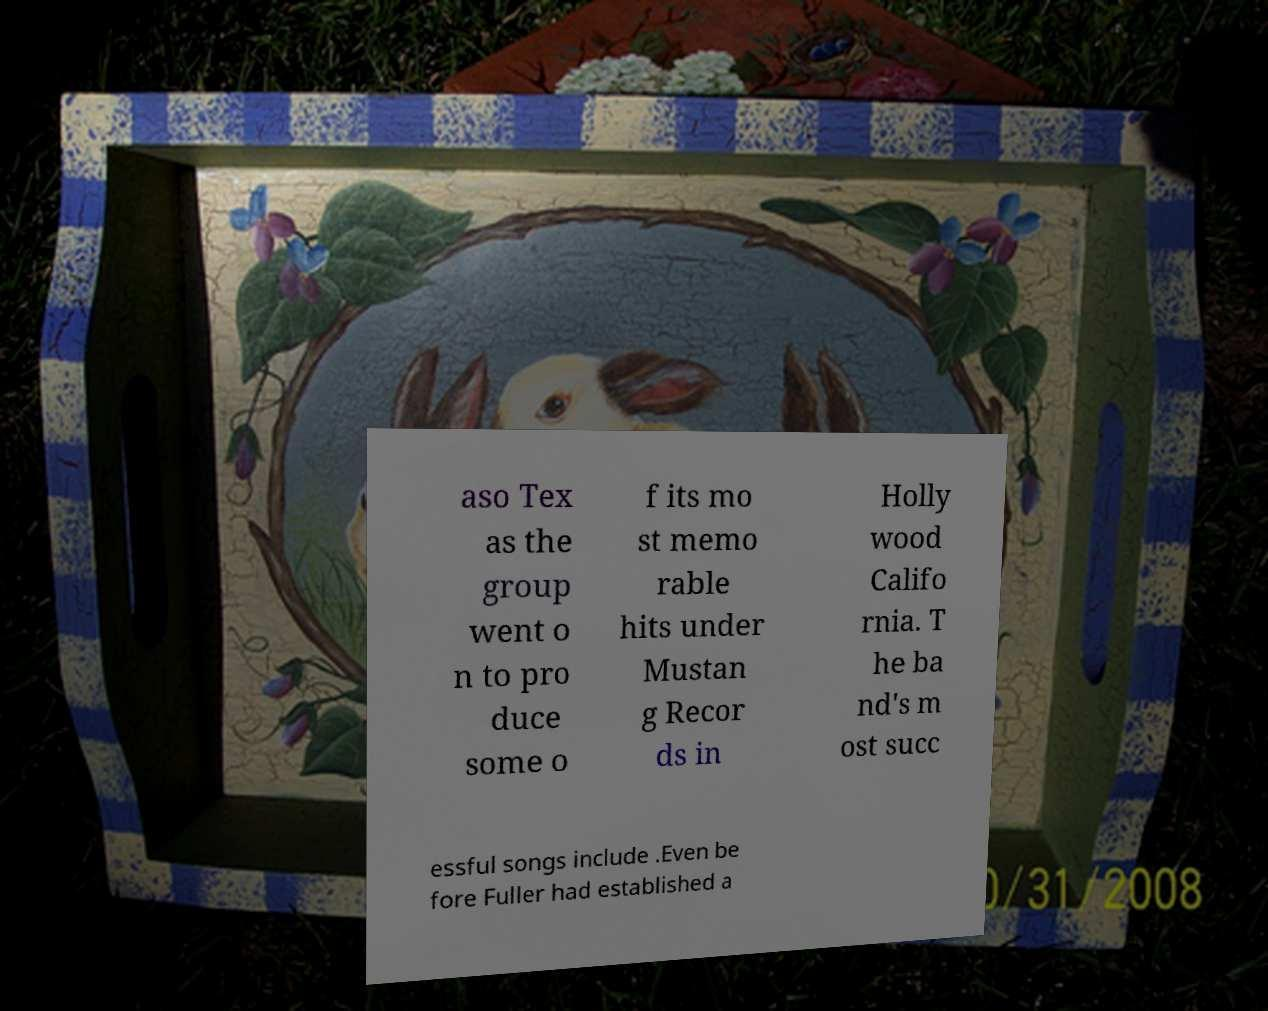There's text embedded in this image that I need extracted. Can you transcribe it verbatim? aso Tex as the group went o n to pro duce some o f its mo st memo rable hits under Mustan g Recor ds in Holly wood Califo rnia. T he ba nd's m ost succ essful songs include .Even be fore Fuller had established a 